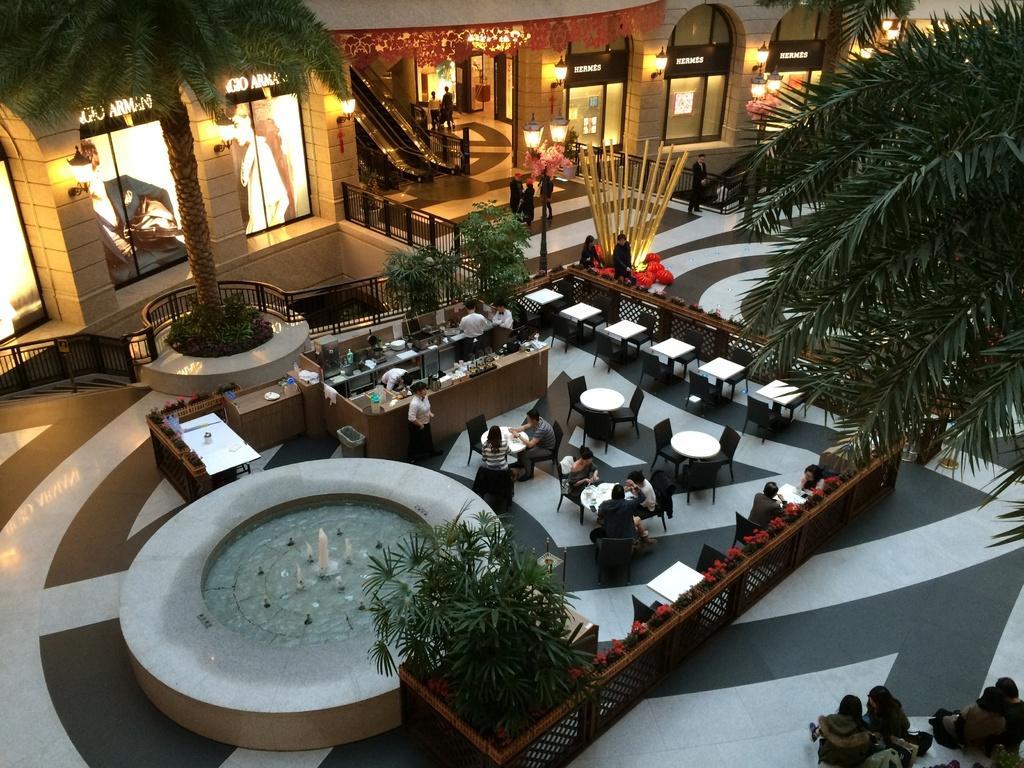In one or two sentences, can you explain what this image depicts? In this picture we can observe some people sitting in the chair around the white color tables. We can observe a desk and some people here. There is a fountain on the left side. There are some plants and trees. In the background we can observe glass doors, escalators and some people. We can observe a black color railing. 